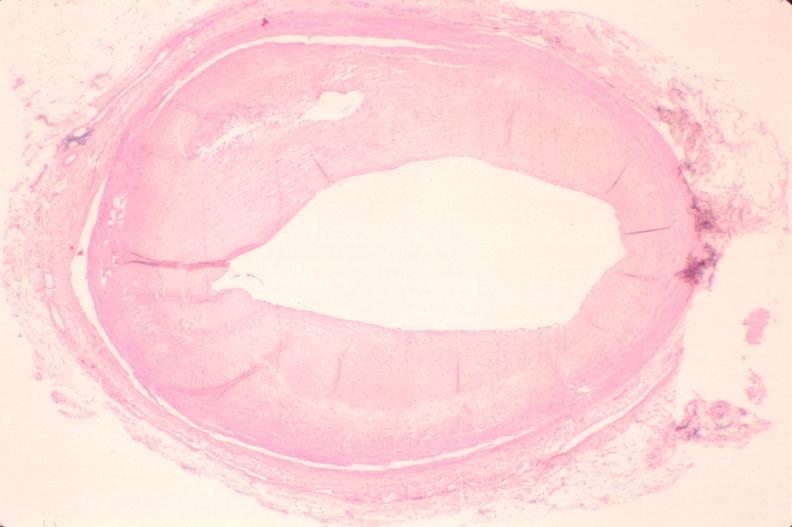where is this in?
Answer the question using a single word or phrase. In vasculature 